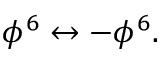Convert formula to latex. <formula><loc_0><loc_0><loc_500><loc_500>\phi ^ { 6 } \leftrightarrow - \phi ^ { 6 } .</formula> 